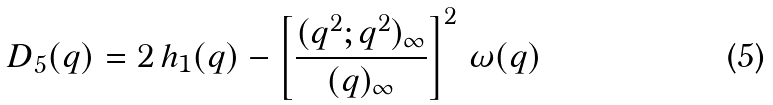Convert formula to latex. <formula><loc_0><loc_0><loc_500><loc_500>D _ { 5 } ( q ) = 2 \, h _ { 1 } ( q ) - \left [ \frac { ( q ^ { 2 } ; q ^ { 2 } ) _ { \infty } } { ( q ) _ { \infty } } \right ] ^ { 2 } \, \omega ( q )</formula> 